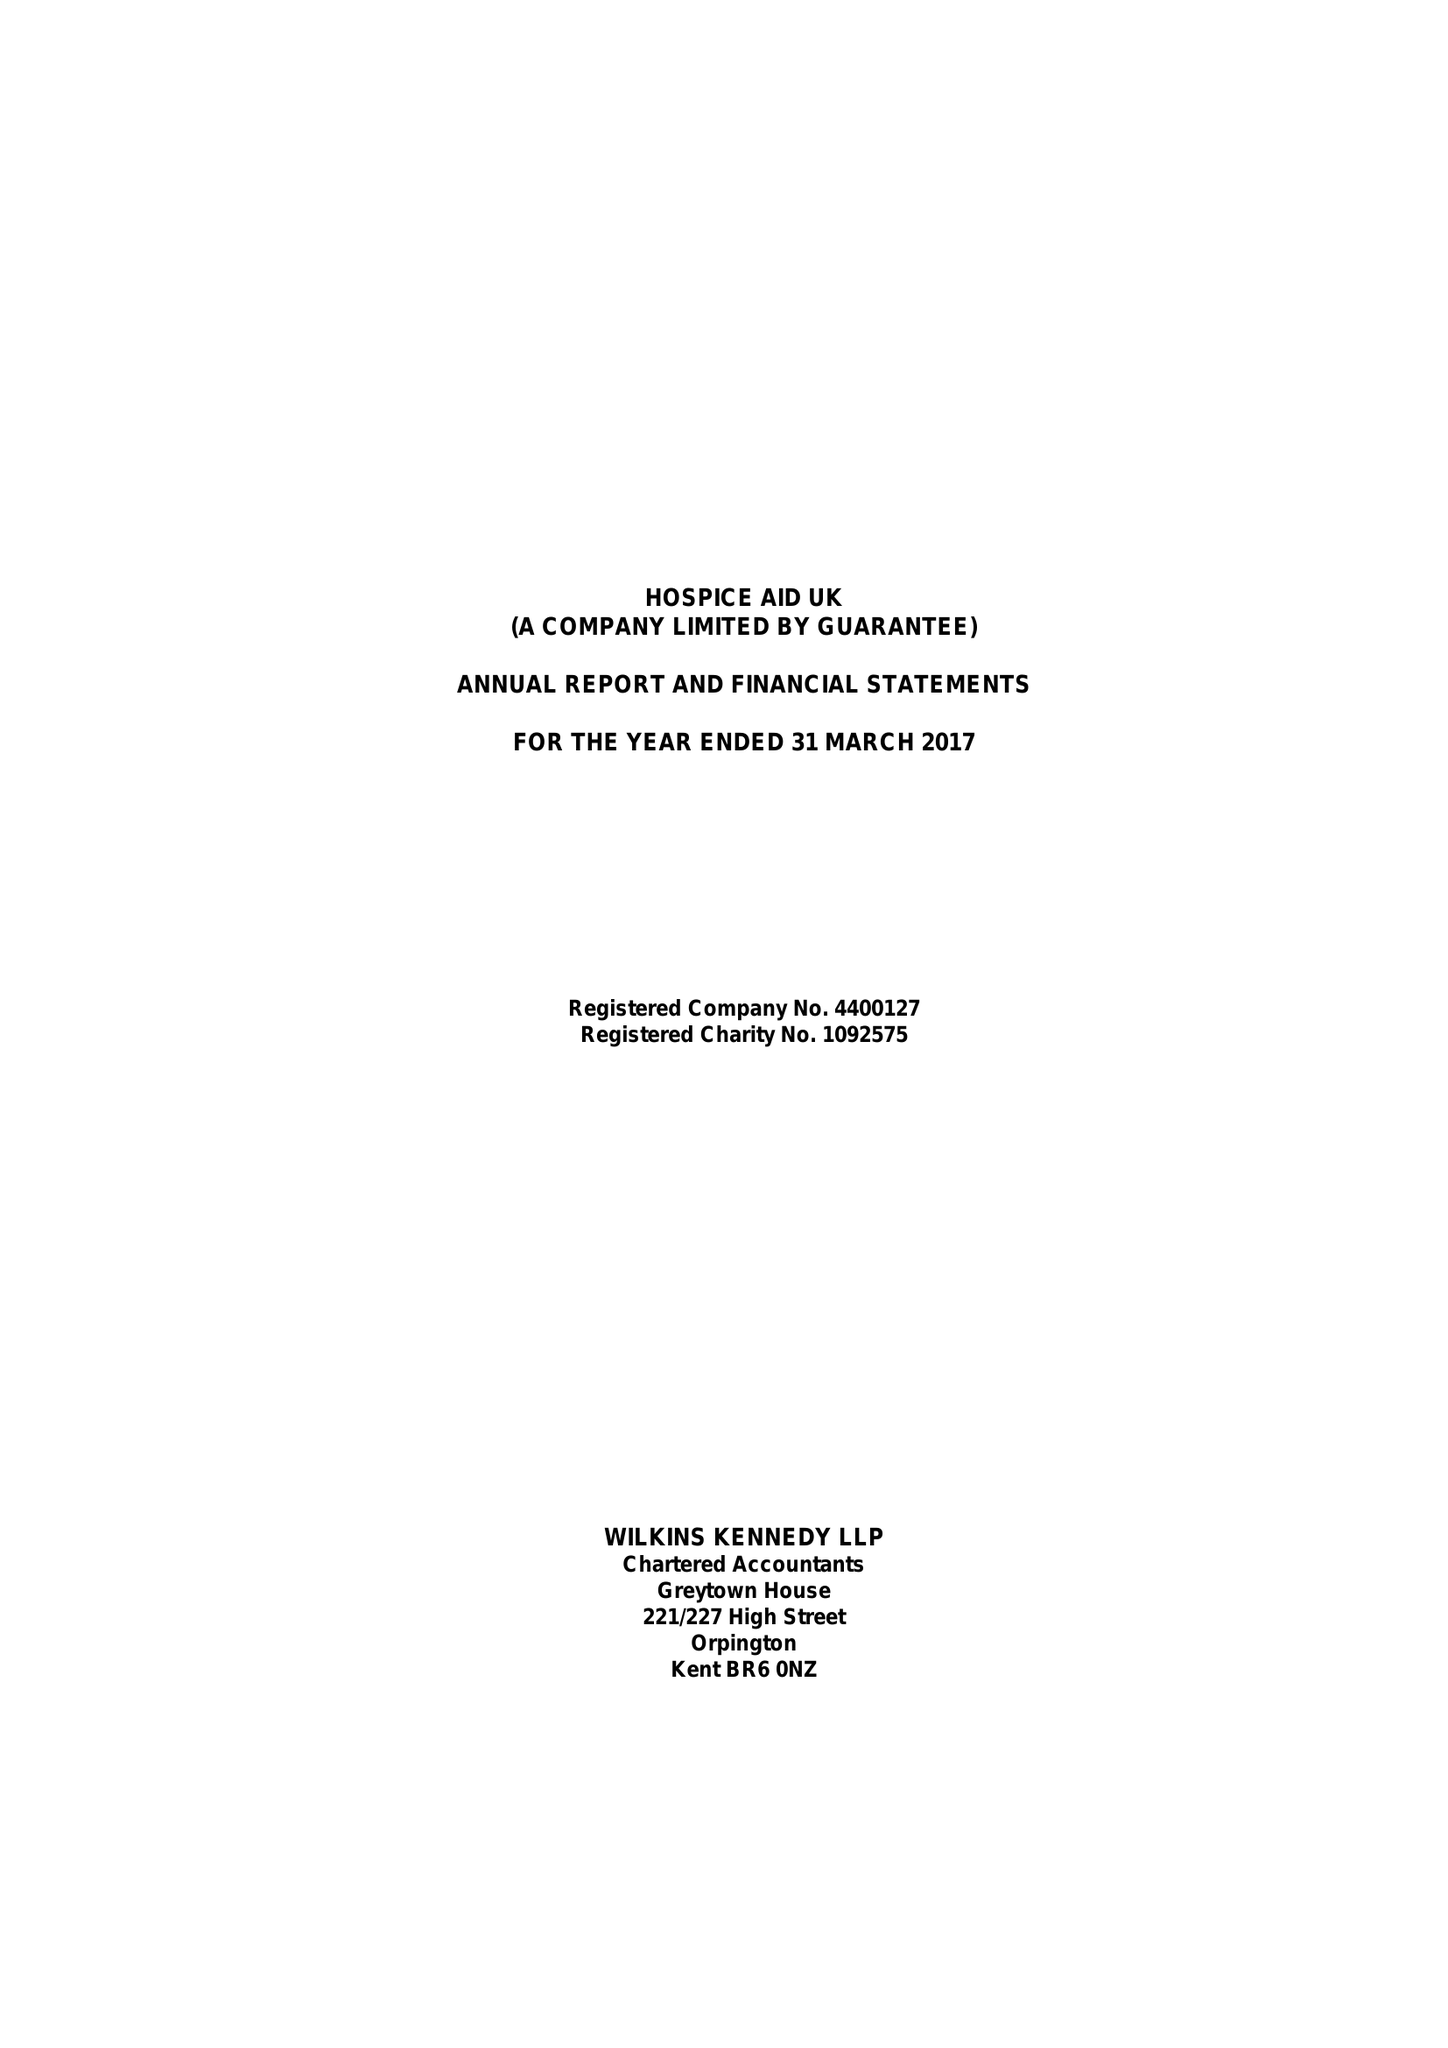What is the value for the charity_name?
Answer the question using a single word or phrase. Hospice Aid Uk 